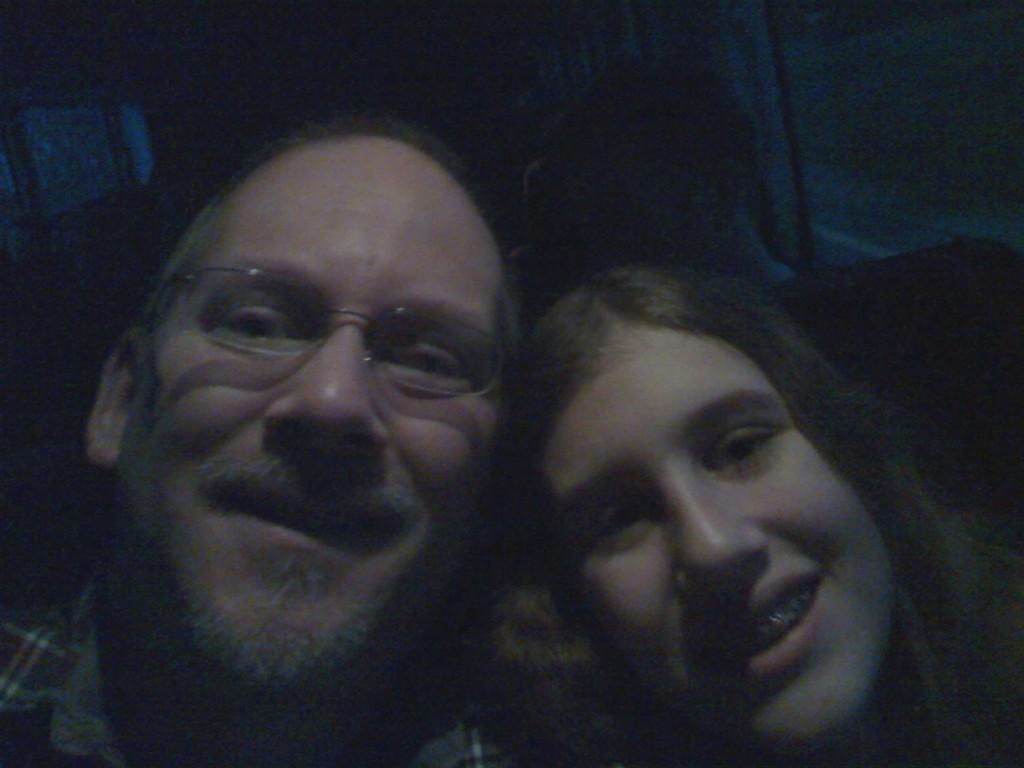What is the person in the image wearing on their face? The person in the image is wearing spectacles. Where is the person located in the image? The person is in the left corner of the image. Who is beside the person in the image? There is a woman beside the person in the image. Where is the woman located in the image? The woman is in the right corner of the image. What memory does the person in the image have about solving a riddle? There is no mention of a memory or a riddle in the image, so we cannot answer that question. 